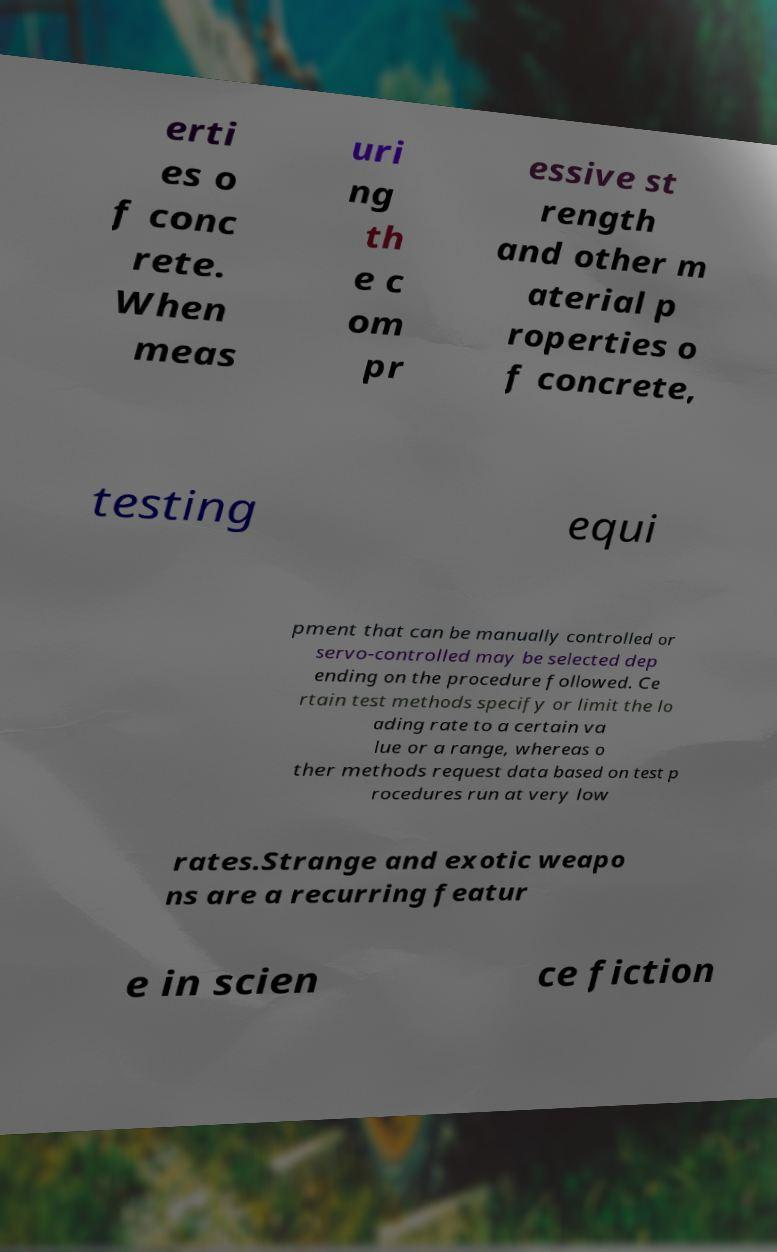Please identify and transcribe the text found in this image. erti es o f conc rete. When meas uri ng th e c om pr essive st rength and other m aterial p roperties o f concrete, testing equi pment that can be manually controlled or servo-controlled may be selected dep ending on the procedure followed. Ce rtain test methods specify or limit the lo ading rate to a certain va lue or a range, whereas o ther methods request data based on test p rocedures run at very low rates.Strange and exotic weapo ns are a recurring featur e in scien ce fiction 